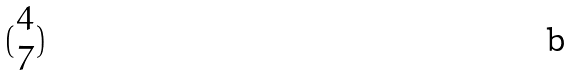Convert formula to latex. <formula><loc_0><loc_0><loc_500><loc_500>( \begin{matrix} 4 \\ 7 \end{matrix} )</formula> 